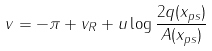<formula> <loc_0><loc_0><loc_500><loc_500>v = - \pi + v _ { R } + u \log \frac { 2 q ( x _ { p s } ) } { A ( x _ { p s } ) }</formula> 